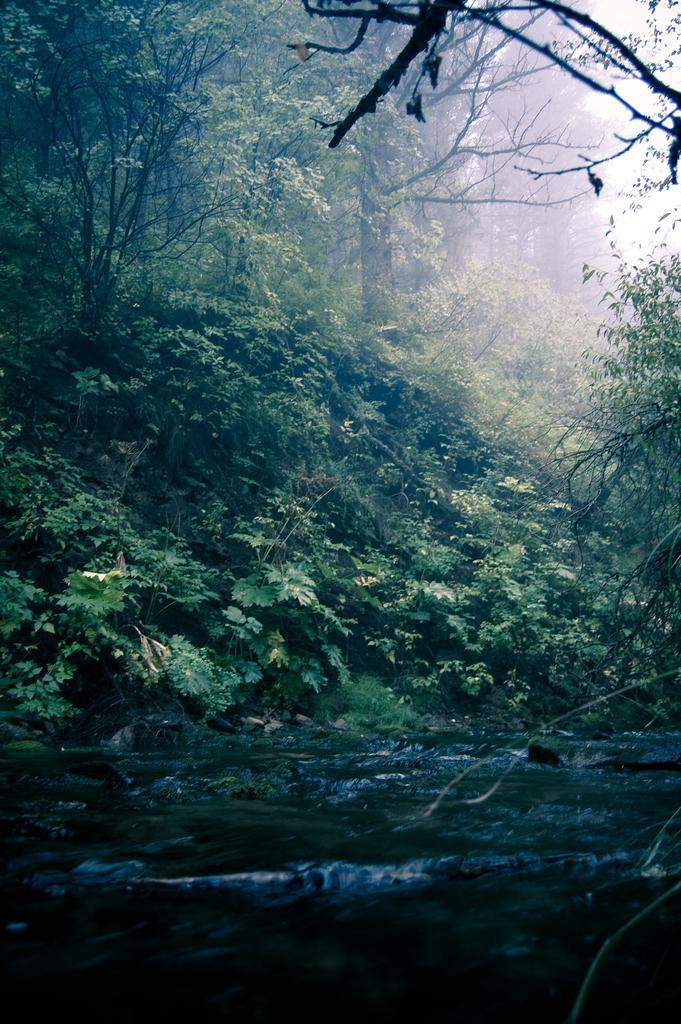Describe this image in one or two sentences. In this picture I can see many trees, plants and grass. At the bottom I can see the water flow. In the top right there is a sky. In the background I can see the fog. 